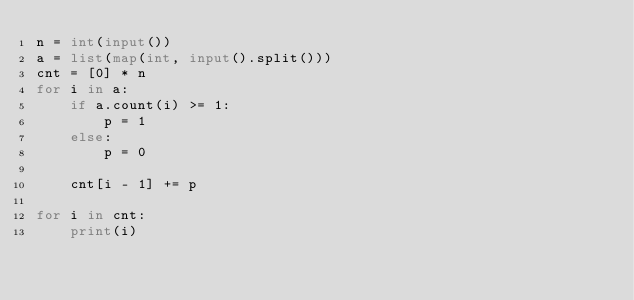<code> <loc_0><loc_0><loc_500><loc_500><_Python_>n = int(input())
a = list(map(int, input().split()))
cnt = [0] * n
for i in a:
    if a.count(i) >= 1:
        p = 1
    else:
        p = 0
        
    cnt[i - 1] += p

for i in cnt:
    print(i)</code> 